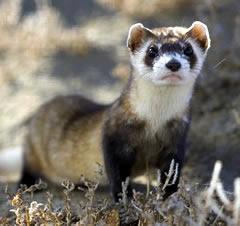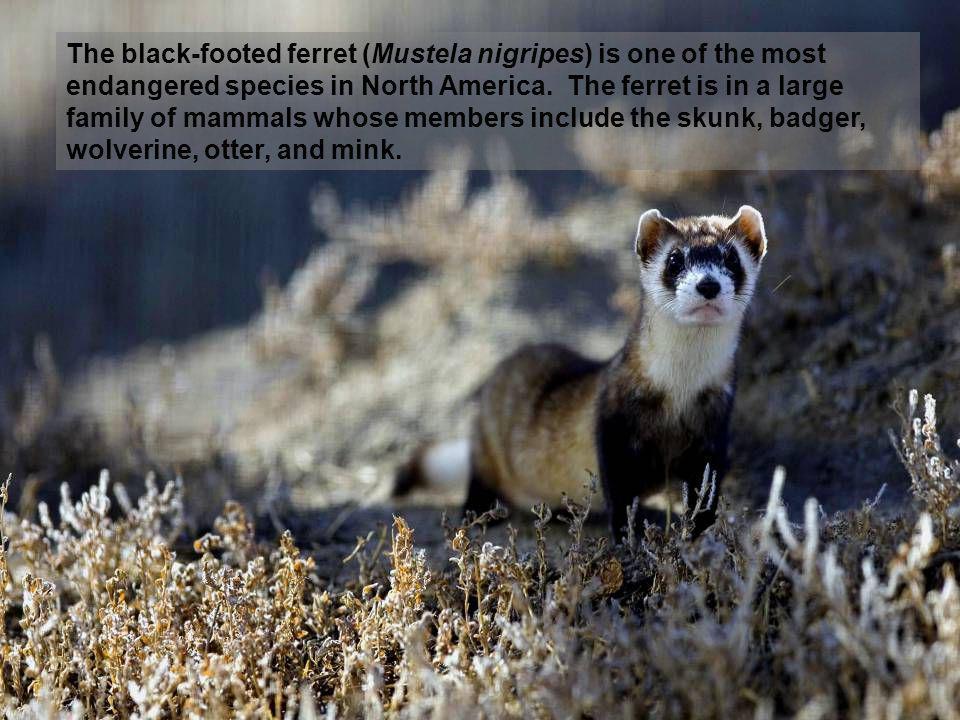The first image is the image on the left, the second image is the image on the right. For the images shown, is this caption "There Is a single brown and white small rodent facing left with black nose." true? Answer yes or no. No. The first image is the image on the left, the second image is the image on the right. Considering the images on both sides, is "There are two black footed ferrets standing outside in the center of the image." valid? Answer yes or no. No. 